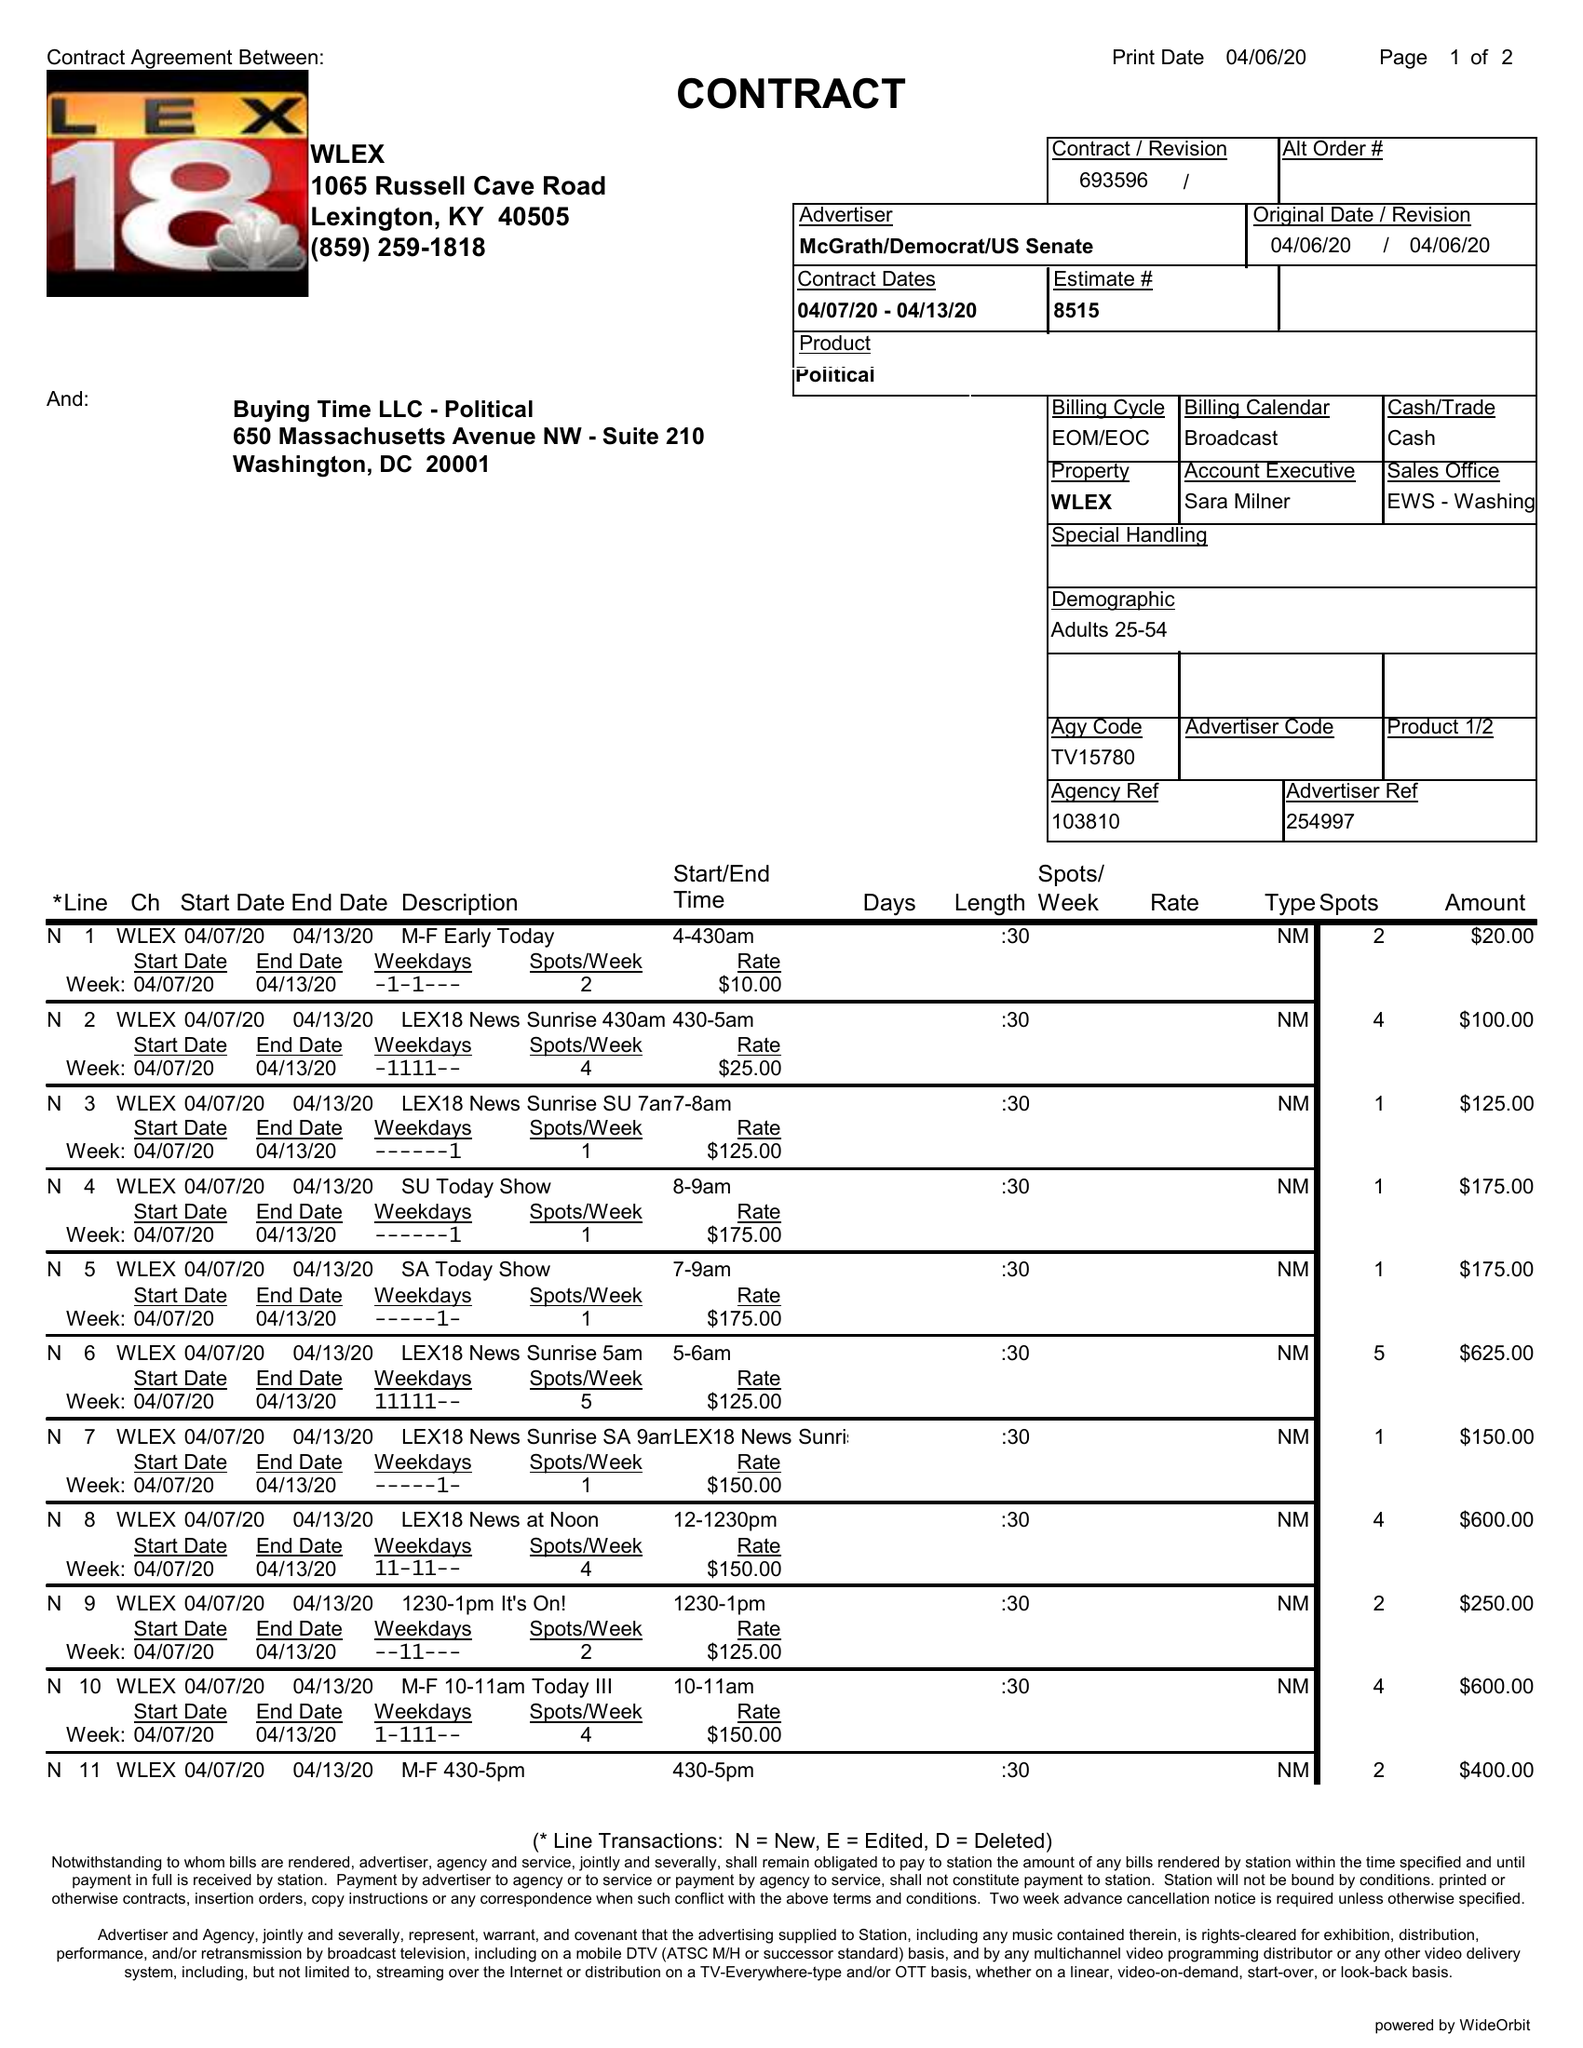What is the value for the flight_to?
Answer the question using a single word or phrase. 04/13/20 